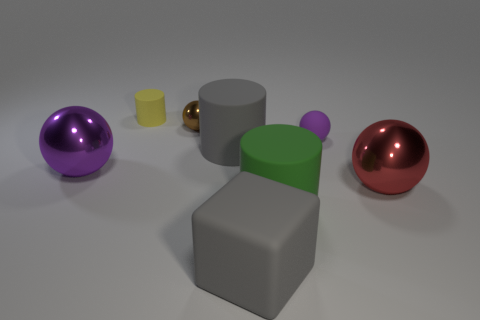What number of green things are tiny rubber blocks or large objects?
Keep it short and to the point. 1. Are there any other big cubes of the same color as the big cube?
Make the answer very short. No. Is there a red cylinder made of the same material as the tiny brown thing?
Offer a very short reply. No. What is the shape of the matte object that is both in front of the small brown sphere and left of the large gray rubber block?
Your answer should be very brief. Cylinder. What number of small things are either brown balls or metallic spheres?
Keep it short and to the point. 1. What material is the small brown object?
Provide a succinct answer. Metal. How many other objects are there of the same shape as the yellow thing?
Provide a short and direct response. 2. What size is the cube?
Offer a very short reply. Large. How big is the shiny object that is both on the right side of the purple metallic sphere and to the left of the red object?
Your answer should be very brief. Small. The metal object right of the purple matte ball has what shape?
Provide a short and direct response. Sphere. 